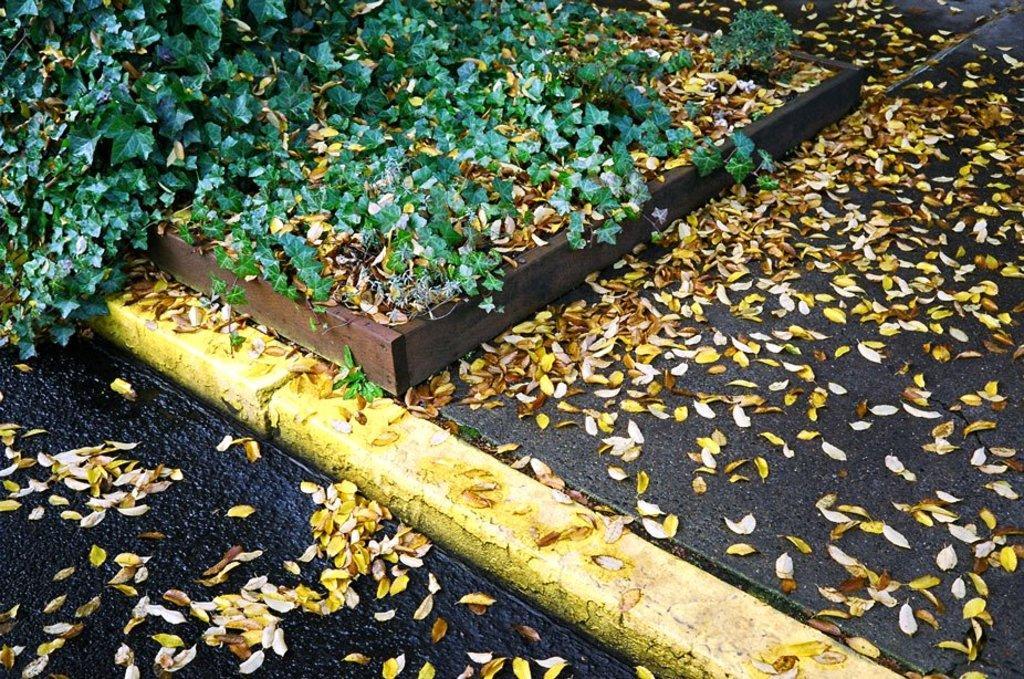Please provide a concise description of this image. In this picture we can see some leaves at the bottom, there are some plants at the top of the picture. 